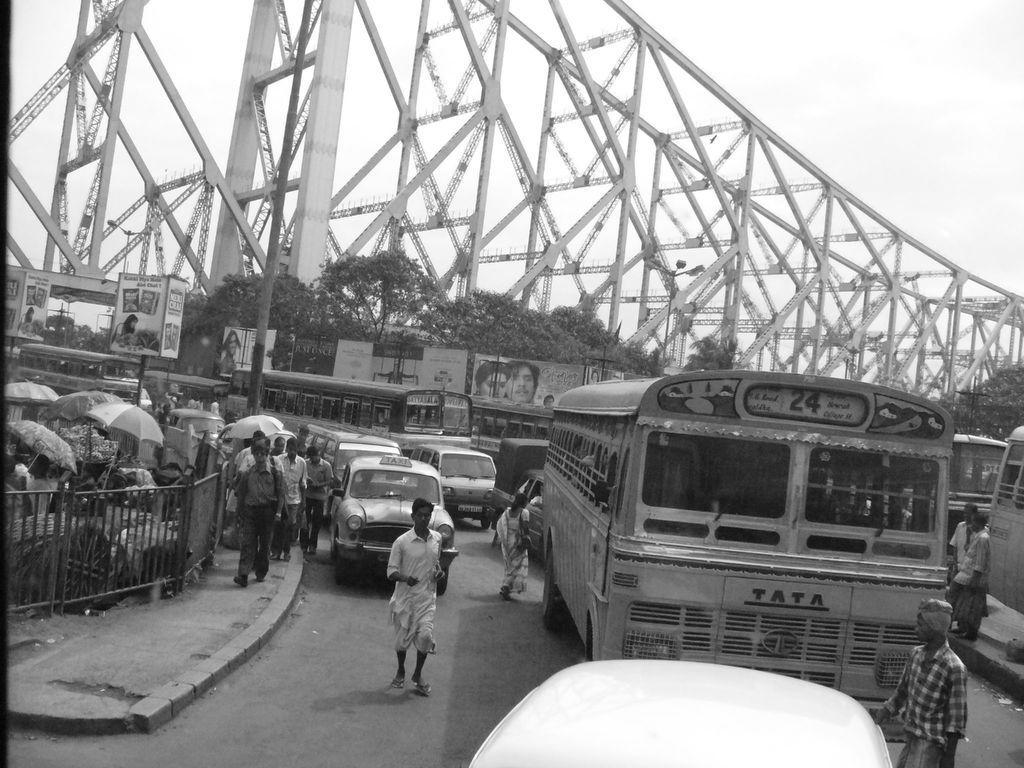Please provide a concise description of this image. In this picture we can see vehicles on the road, some people are walking on the footpath, fence, umbrellas and some objects. In the background we can see banners, trees, bridge and the sky. 